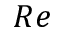<formula> <loc_0><loc_0><loc_500><loc_500>R e</formula> 